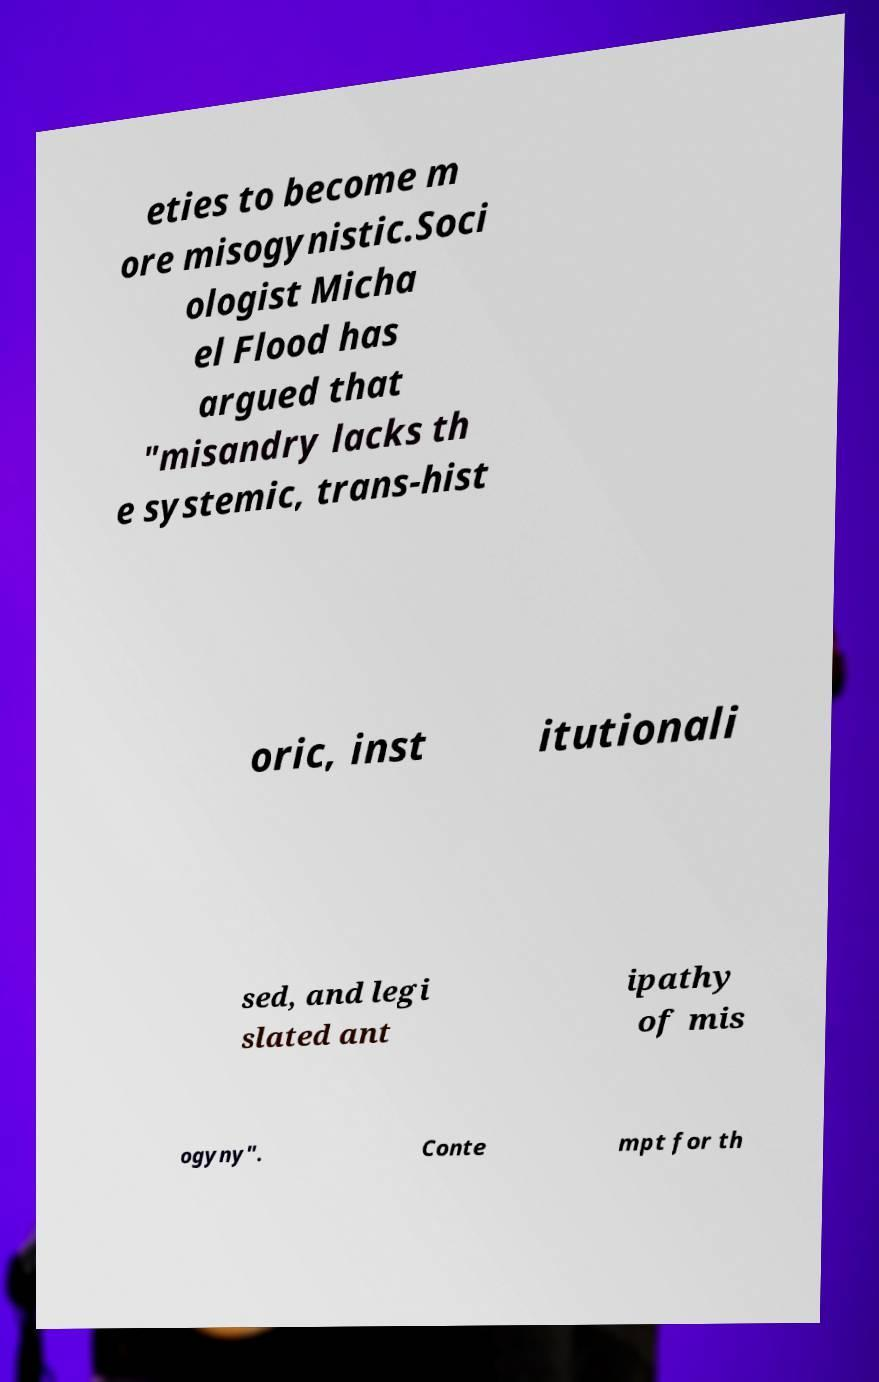Can you accurately transcribe the text from the provided image for me? eties to become m ore misogynistic.Soci ologist Micha el Flood has argued that "misandry lacks th e systemic, trans-hist oric, inst itutionali sed, and legi slated ant ipathy of mis ogyny". Conte mpt for th 